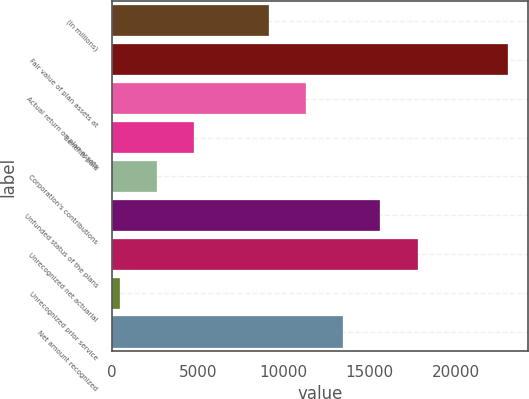Convert chart. <chart><loc_0><loc_0><loc_500><loc_500><bar_chart><fcel>(In millions)<fcel>Fair value of plan assets at<fcel>Actual return on plan assets<fcel>Benefits paid<fcel>Corporation's contributions<fcel>Unfunded status of the plans<fcel>Unrecognized net actuarial<fcel>Unrecognized prior service<fcel>Net amount recognized<nl><fcel>9132.2<fcel>23080.8<fcel>11300<fcel>4796.6<fcel>2628.8<fcel>15635.6<fcel>17803.4<fcel>461<fcel>13467.8<nl></chart> 